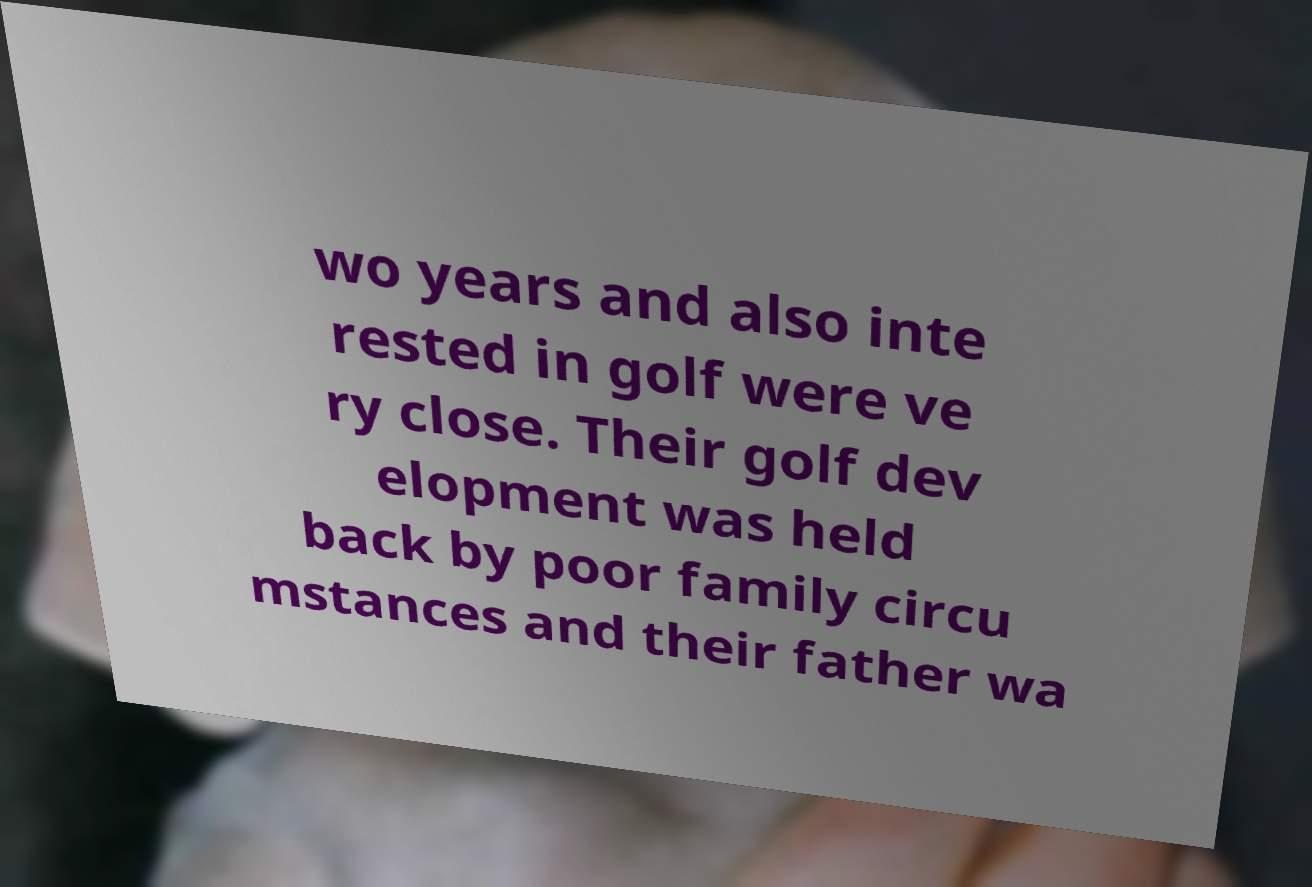I need the written content from this picture converted into text. Can you do that? wo years and also inte rested in golf were ve ry close. Their golf dev elopment was held back by poor family circu mstances and their father wa 